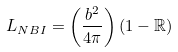Convert formula to latex. <formula><loc_0><loc_0><loc_500><loc_500>L _ { N B I } = \left ( \frac { b ^ { 2 } } { 4 \pi } \right ) \left ( 1 - \mathbb { R } \right )</formula> 